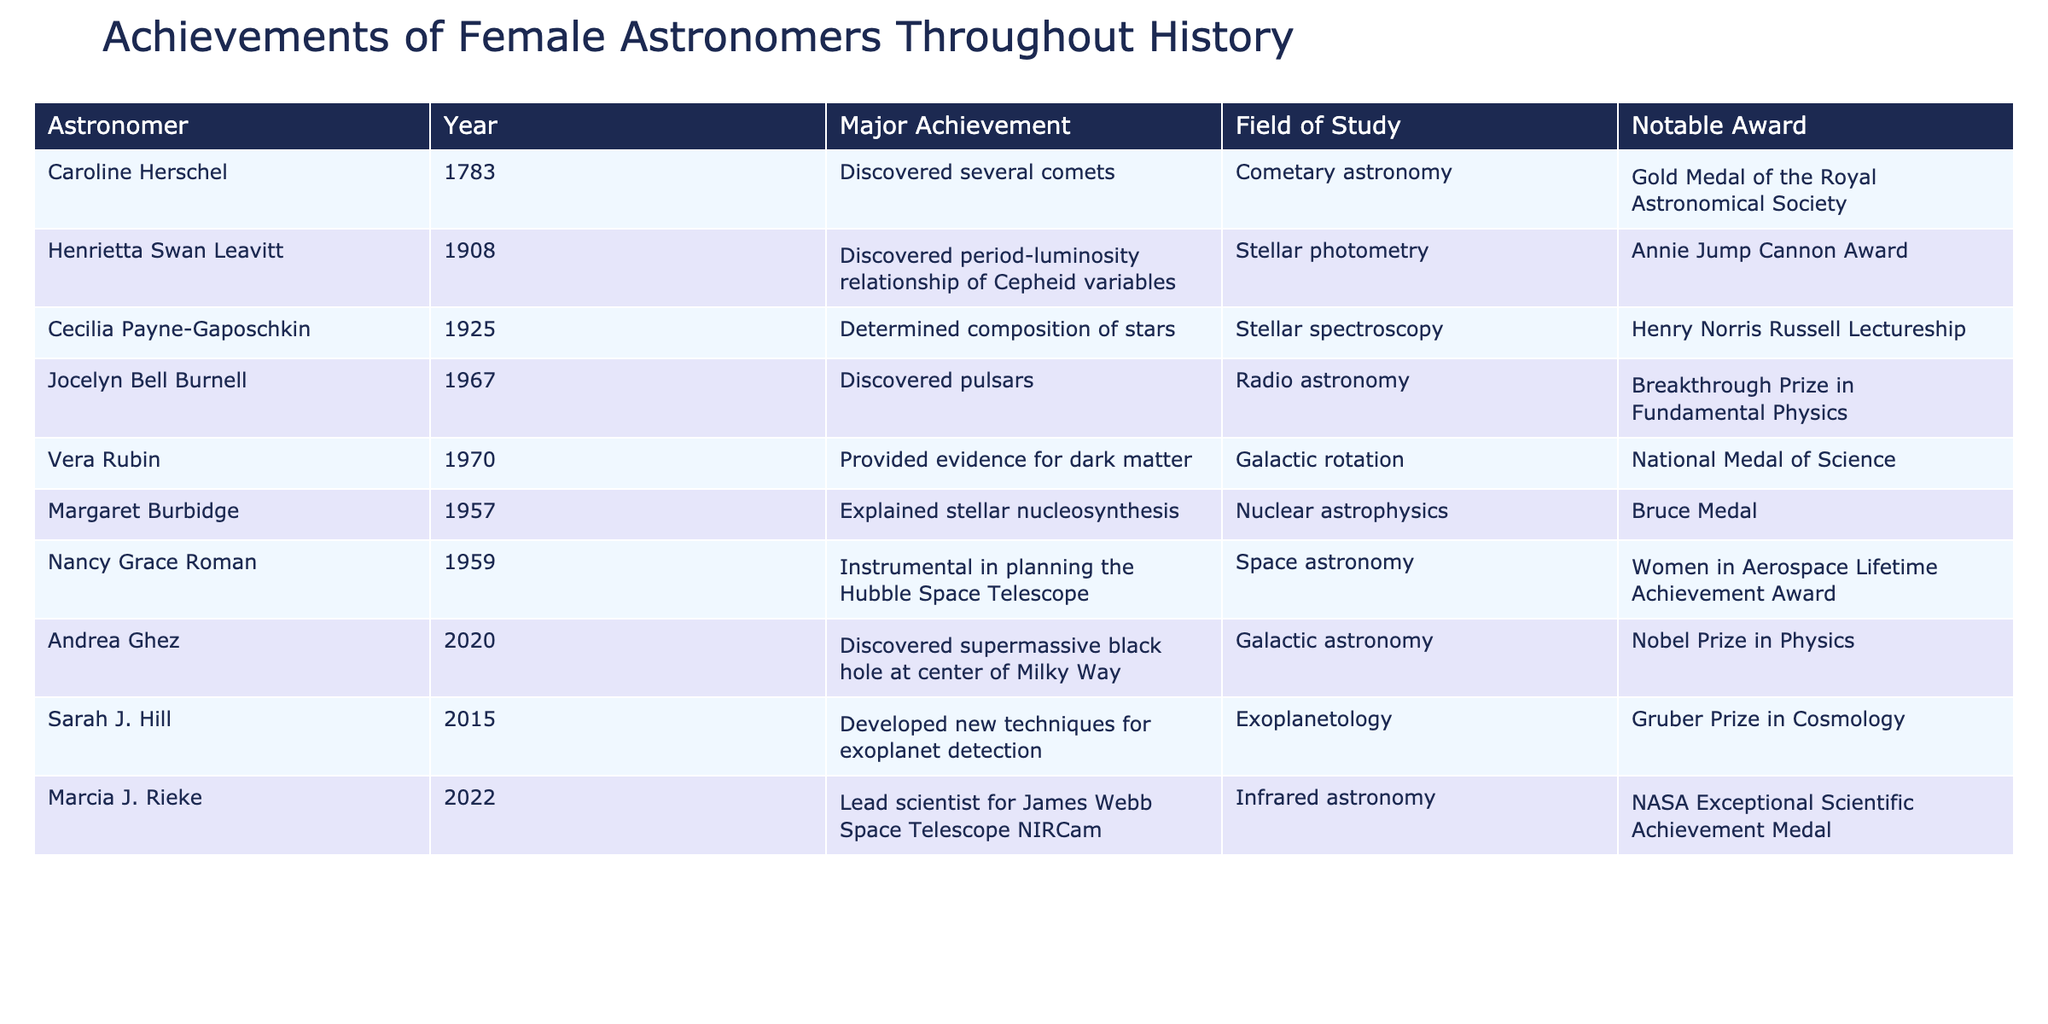What major achievement did Jocelyn Bell Burnell accomplish? Referring to the table, Jocelyn Bell Burnell's major achievement listed is the discovery of pulsars in 1967.
Answer: Discovered pulsars Who received the Nobel Prize in Physics among the astronomers listed? From the table, Andrea Ghez is the astronomer who received the Nobel Prize in Physics in 2020 for discovering the supermassive black hole at the center of the Milky Way.
Answer: Andrea Ghez How many achievements are related to stellar studies (stellar photometry, spectroscopy, etc.)? The table lists three astronomers in the field of stellar studies: Henrietta Swan Leavitt, Cecilia Payne-Gaposchkin, and Margaret Burbidge. This counts as three achievements.
Answer: 3 True or False: Nancy Grace Roman was awarded the Gold Medal of the Royal Astronomical Society. According to the table, Nancy Grace Roman received the Women in Aerospace Lifetime Achievement Award, not the Gold Medal of the Royal Astronomical Society which was awarded to Caroline Herschel.
Answer: False What is the difference in the year of achievement between Caroline Herschel and Andrea Ghez? Caroline Herschel's achievement year is 1783 and Andrea Ghez's is 2020. The difference is 2020 - 1783 = 237 years.
Answer: 237 years What fields of study are represented by the achievements listed? A review of the table shows that the fields of study include Cometary astronomy, Stellar photometry, Stellar spectroscopy, Radio astronomy, Galactic rotation, Nuclear astrophysics, Space astronomy, Galactic astronomy, and Exoplanetology.
Answer: 9 fields Which astronaut's achievements span the greatest time period between the first and last entries? The time period spans from Caroline Herschel's achievement in 1783 to Marcia J. Rieke in 2022, which is a total of 239 years. This indicates the longest span across the table's entries.
Answer: 239 years How many women made significant contributions related to dark matter? From the table, only Vera Rubin provided evidence for dark matter, which indicates a singular contribution focused on this topic.
Answer: 1 Which two astronomers have contributed to the exploration of exoplanets and astronomy beyond our galaxy? Sarah J. Hill developed techniques for exoplanet detection, and Andrea Ghez discovered a supermassive black hole, representing contributions in exoplanet research and galactic studies, respectively.
Answer: 2 